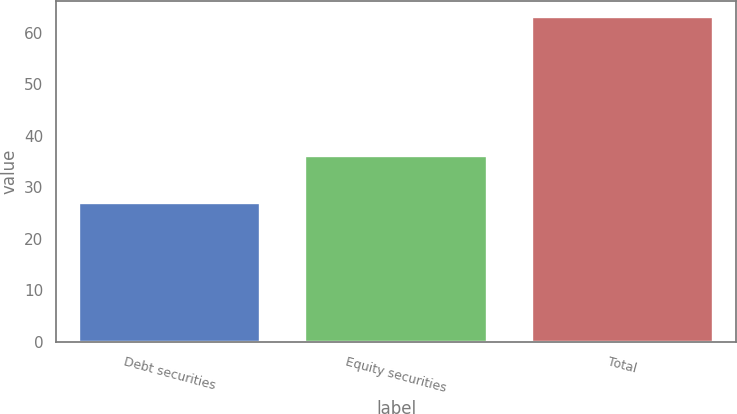Convert chart. <chart><loc_0><loc_0><loc_500><loc_500><bar_chart><fcel>Debt securities<fcel>Equity securities<fcel>Total<nl><fcel>27<fcel>36<fcel>63<nl></chart> 